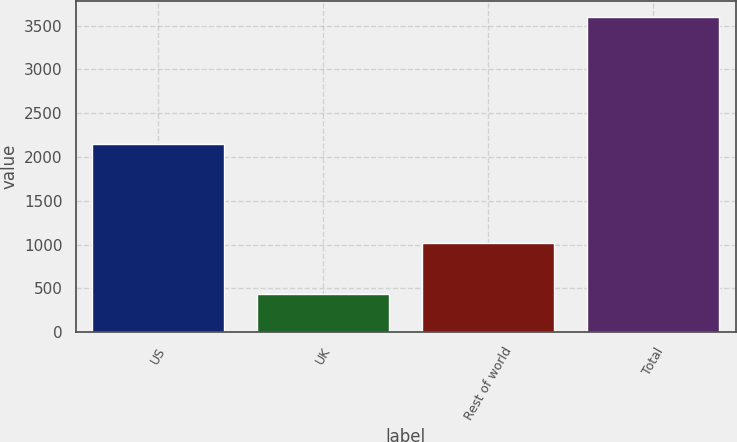Convert chart to OTSL. <chart><loc_0><loc_0><loc_500><loc_500><bar_chart><fcel>US<fcel>UK<fcel>Rest of world<fcel>Total<nl><fcel>2152<fcel>435.4<fcel>1012.3<fcel>3599.7<nl></chart> 